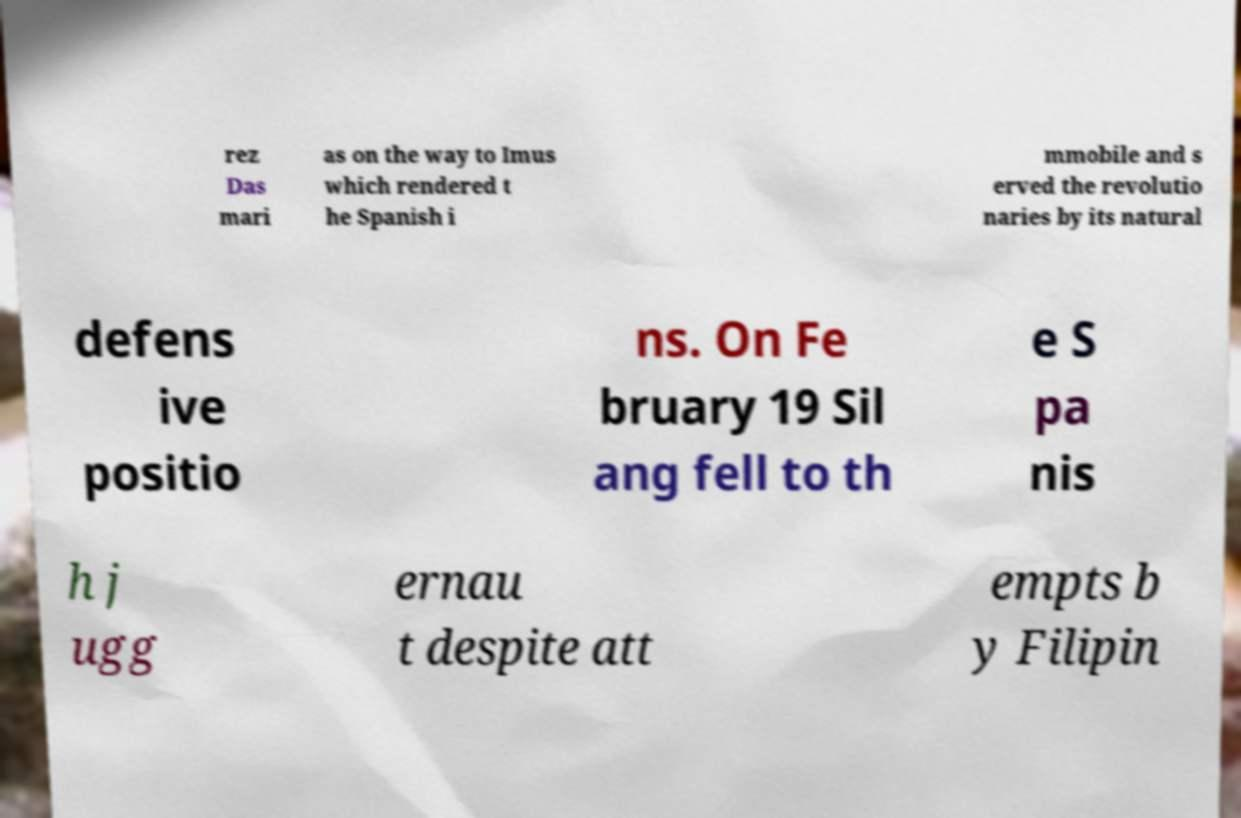Could you extract and type out the text from this image? rez Das mari as on the way to Imus which rendered t he Spanish i mmobile and s erved the revolutio naries by its natural defens ive positio ns. On Fe bruary 19 Sil ang fell to th e S pa nis h j ugg ernau t despite att empts b y Filipin 